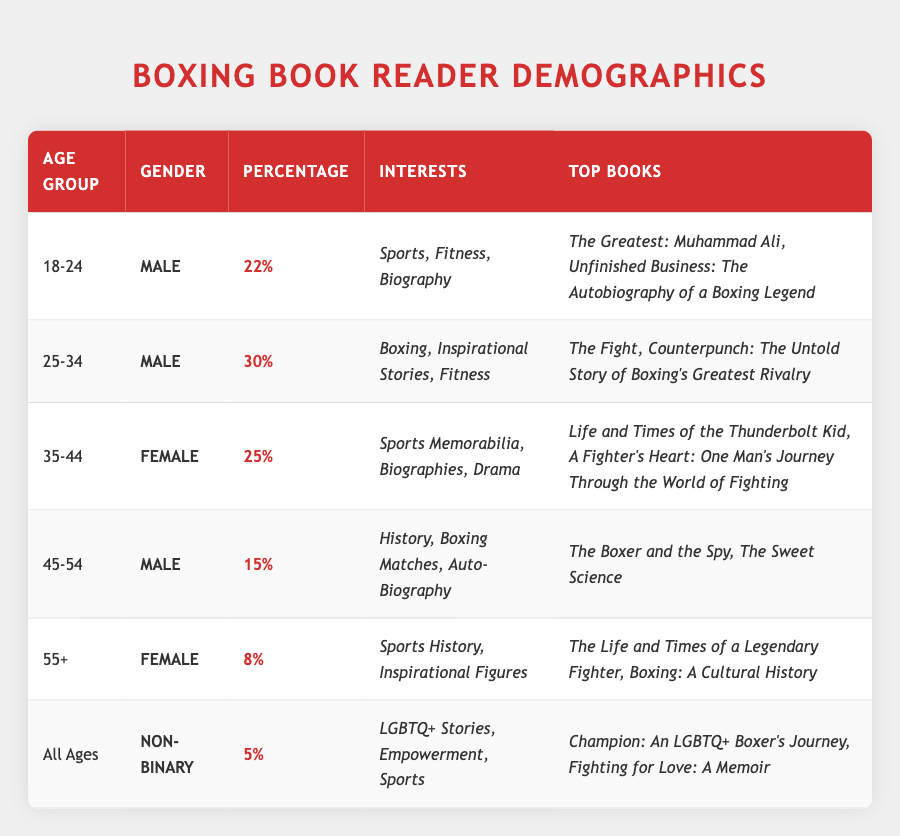What percentage of readers aged 25-34 are male? The table shows that the age group "25-34" has a gender marked as "Male" with a percentage of "30%" listed alongside.
Answer: 30% Which age group has the highest percentage of readership? The table indicates the percentages for each age group: 22% for 18-24, 30% for 25-34, 25% for 35-44, 15% for 45-54, 8% for 55+, and 5% for all ages. By comparing these values, "25-34" has the highest percentage of 30%.
Answer: 25-34 Is the majority of boxing-themed book readers male? By looking at the gender distribution in the table, we find that most age groups (18-24, 25-34, 45-54) are male, with percentages totaling 22% + 30% + 15% = 67%, while the only female group is the 35-44 age group (25%). Hence, yes, the majority are male.
Answer: Yes What are the top books for readers aged 55 and older? The table specifies that the age group "55+" has the following top books: "The Life and Times of a Legendary Fighter" and "Boxing: A Cultural History". This information is directly available in the "Top Books" section for that age group.
Answer: The Life and Times of a Legendary Fighter, Boxing: A Cultural History Calculate the average percentage of readers across all age groups. To find the average, we sum up all the percentages: 22 + 30 + 25 + 15 + 8 + 5 = 105. Then, we divide this sum by the number of age groups, which is 6: 105 / 6 = 17.5.
Answer: 17.5 